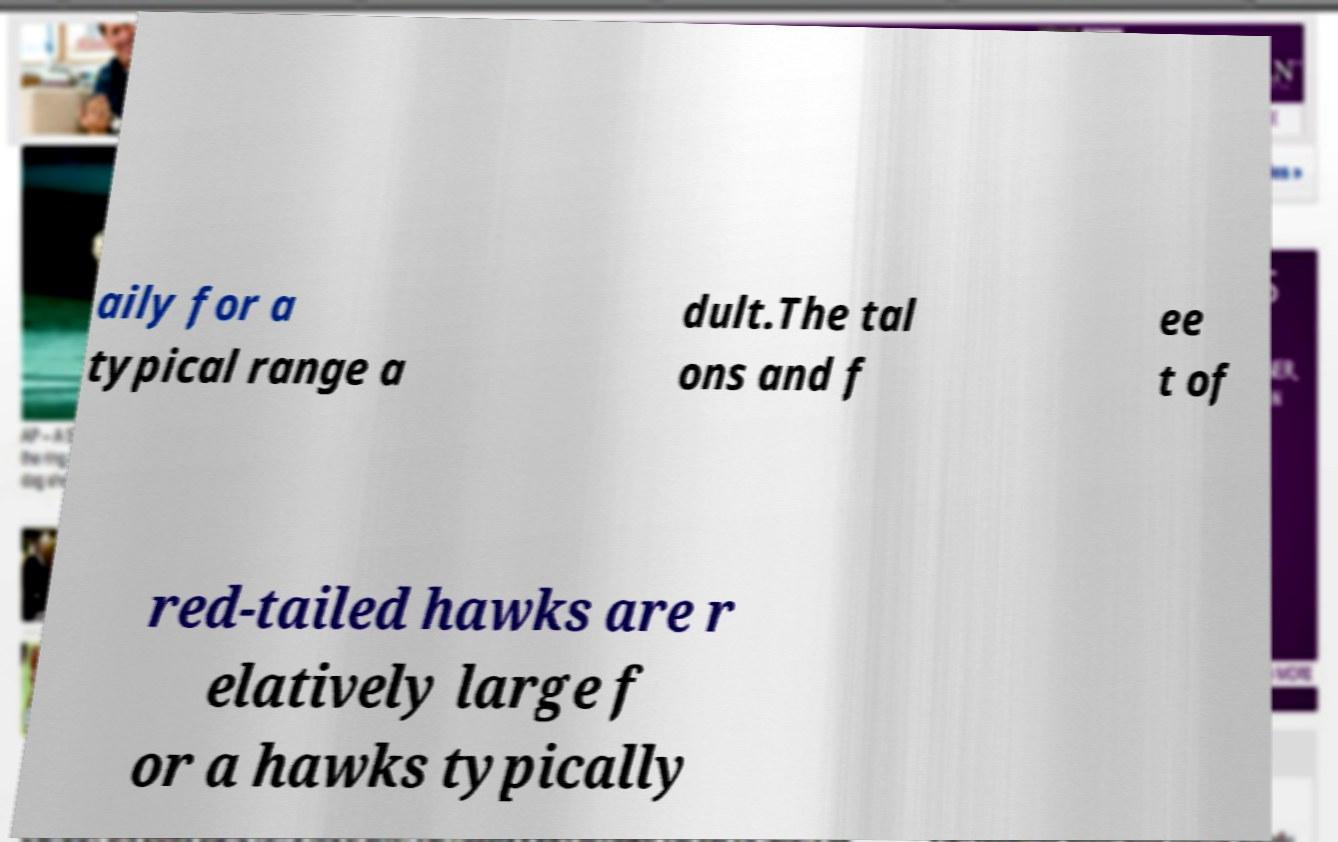Could you extract and type out the text from this image? aily for a typical range a dult.The tal ons and f ee t of red-tailed hawks are r elatively large f or a hawks typically 